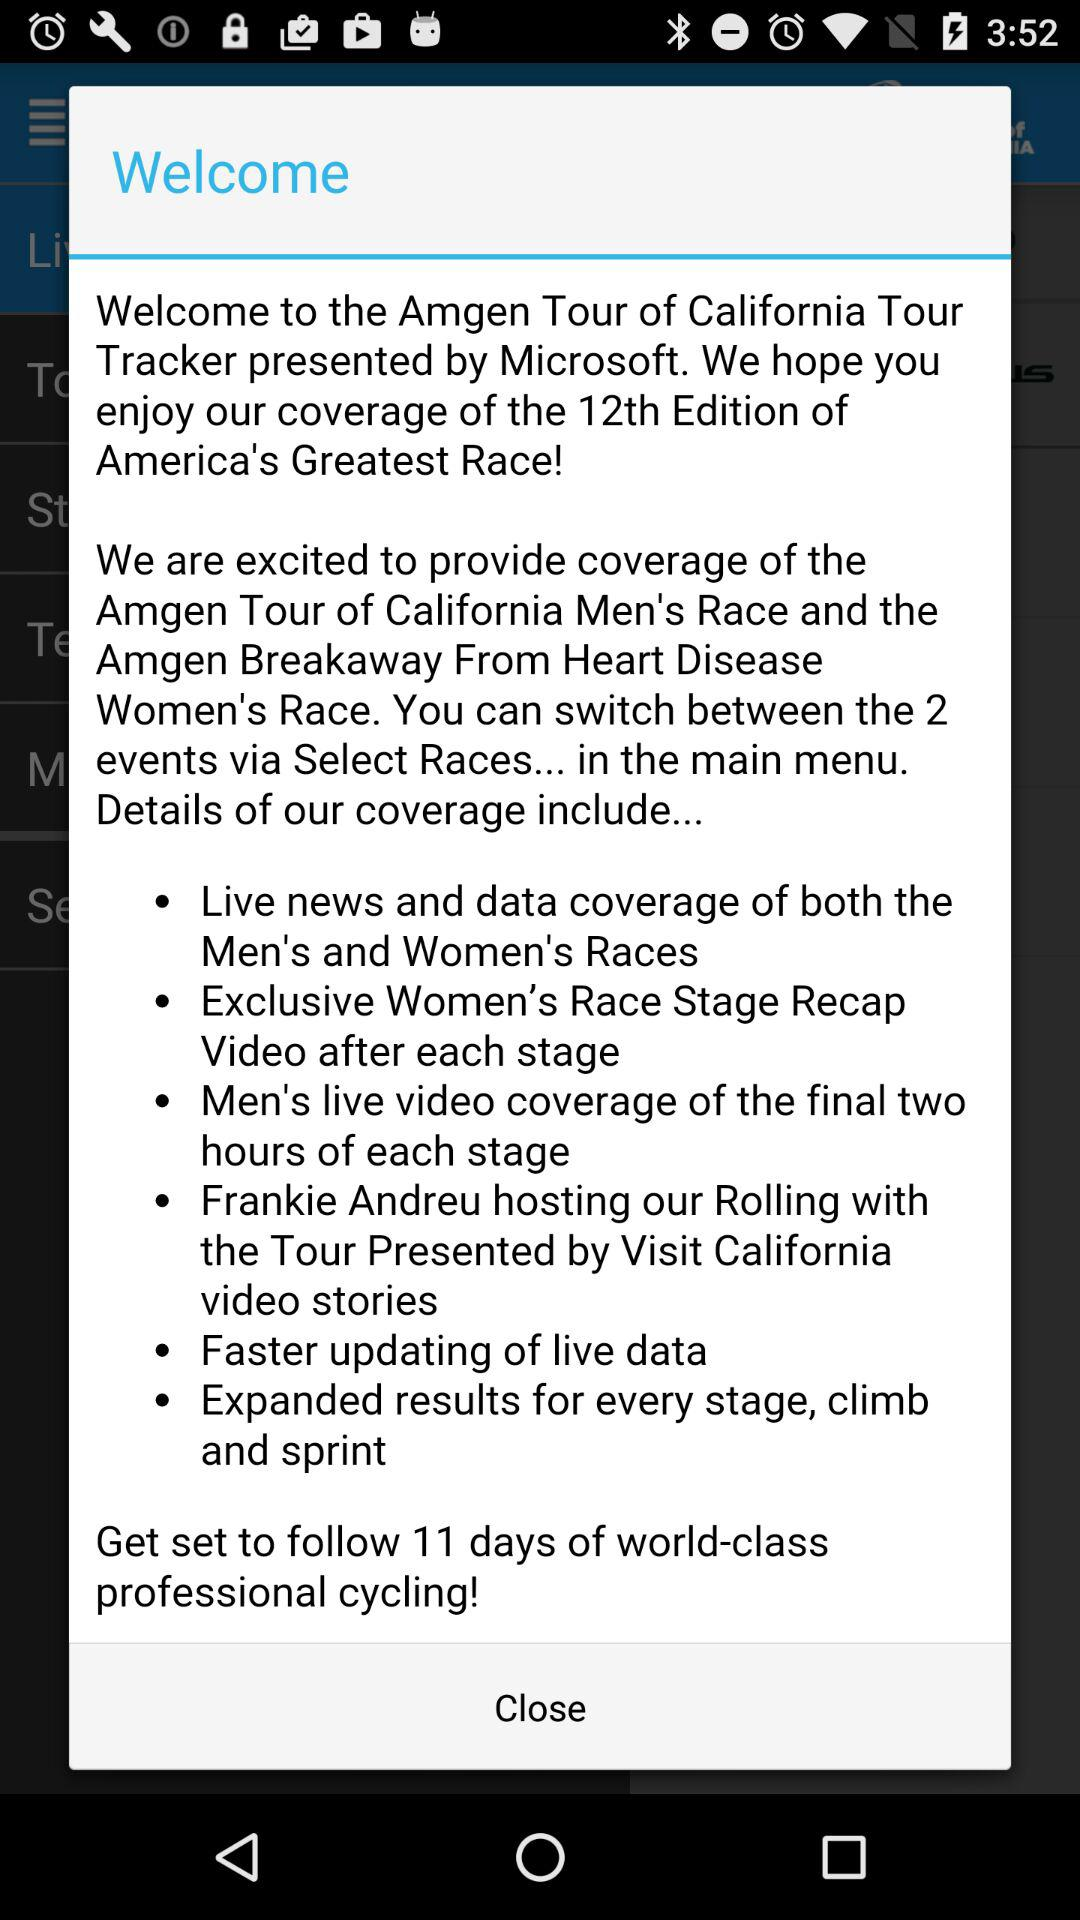What is the event name? The event names are "Amgen Tour of California Men's Race" and "Amgen Breakaway From Heart Disease Women's Race". 